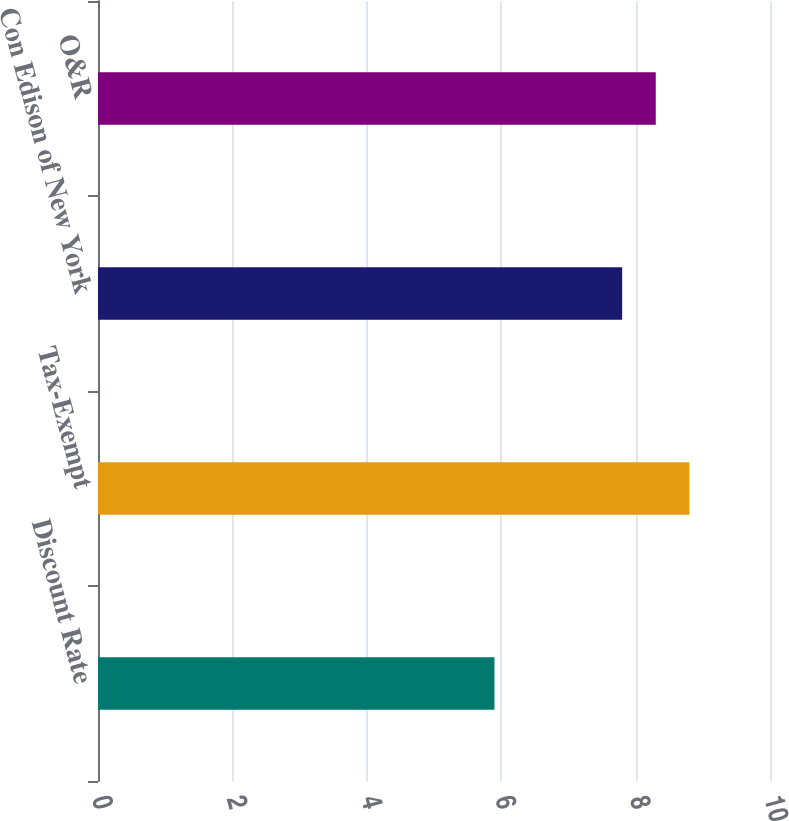Convert chart. <chart><loc_0><loc_0><loc_500><loc_500><bar_chart><fcel>Discount Rate<fcel>Tax-Exempt<fcel>Con Edison of New York<fcel>O&R<nl><fcel>5.9<fcel>8.8<fcel>7.8<fcel>8.3<nl></chart> 